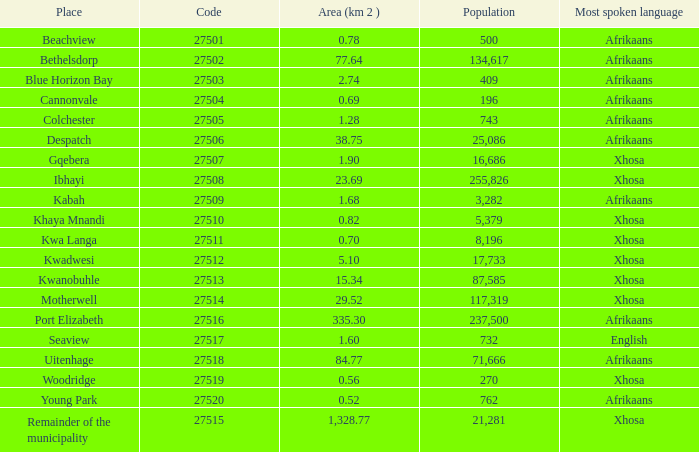What is the aggregate code number for places having a population greater than 87,585? 4.0. 